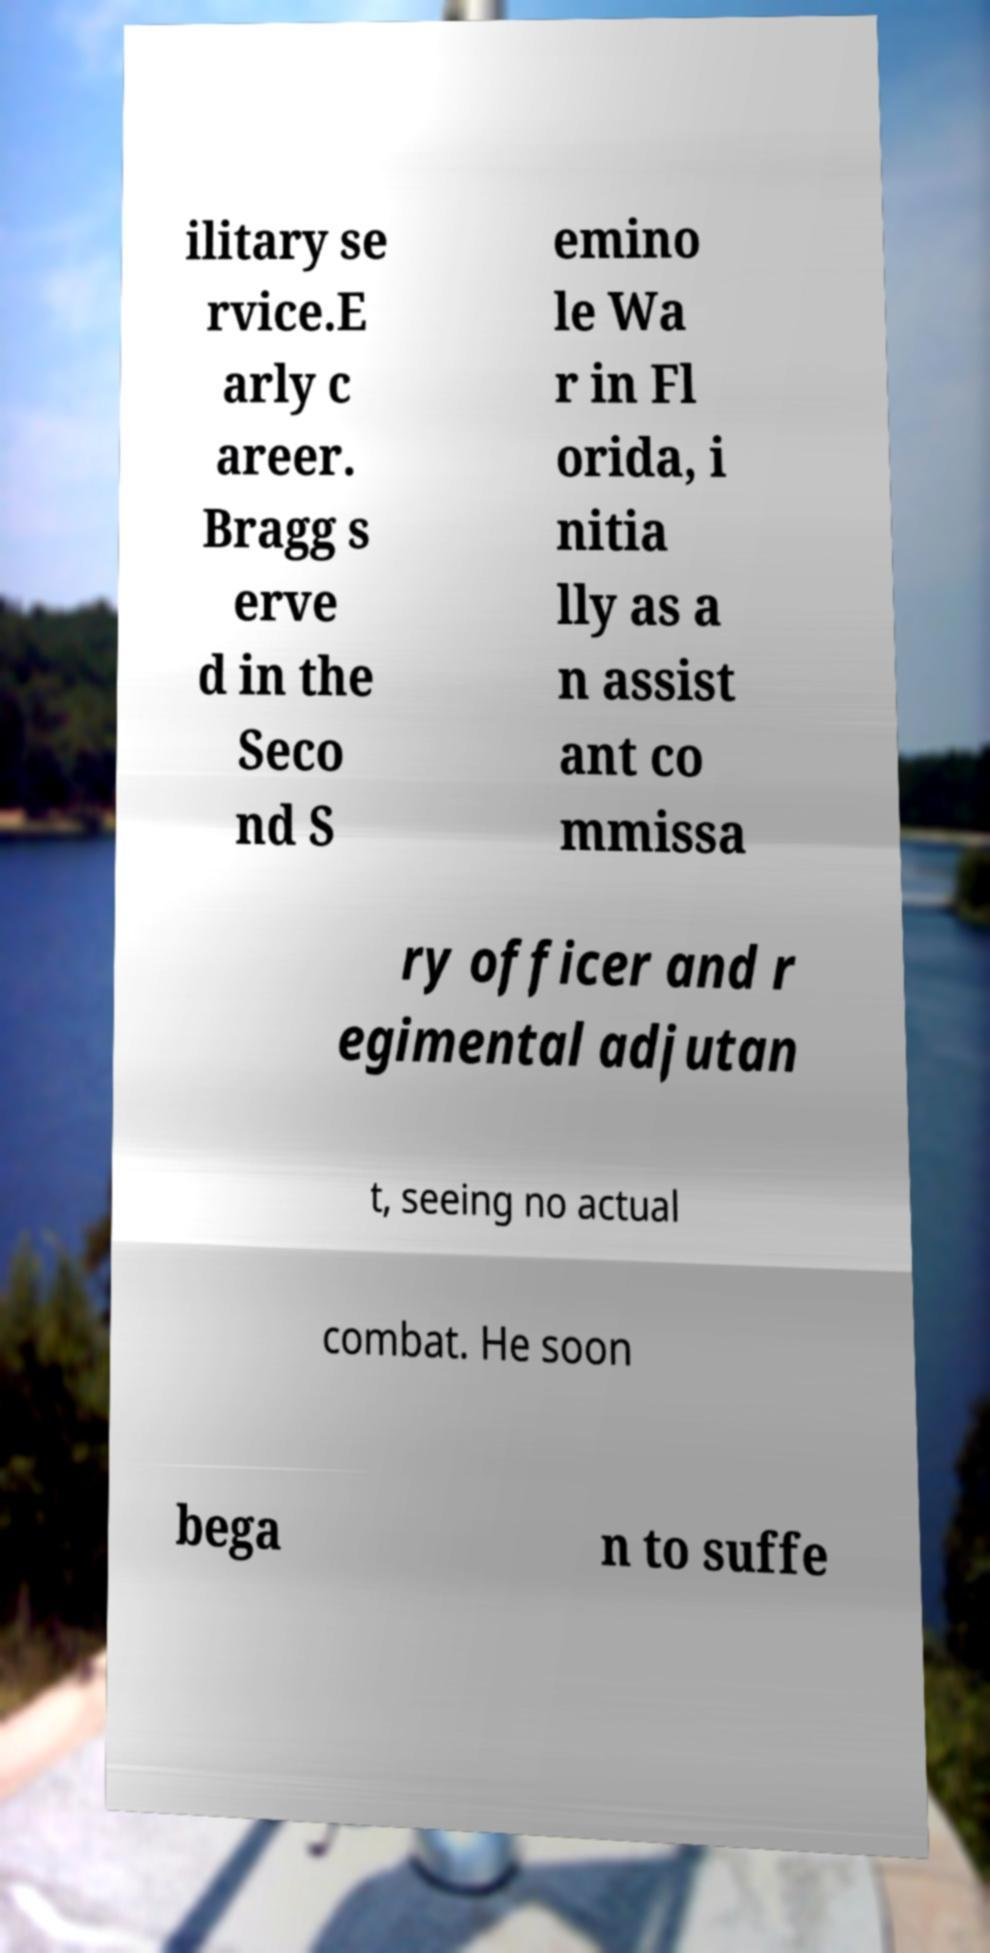I need the written content from this picture converted into text. Can you do that? ilitary se rvice.E arly c areer. Bragg s erve d in the Seco nd S emino le Wa r in Fl orida, i nitia lly as a n assist ant co mmissa ry officer and r egimental adjutan t, seeing no actual combat. He soon bega n to suffe 